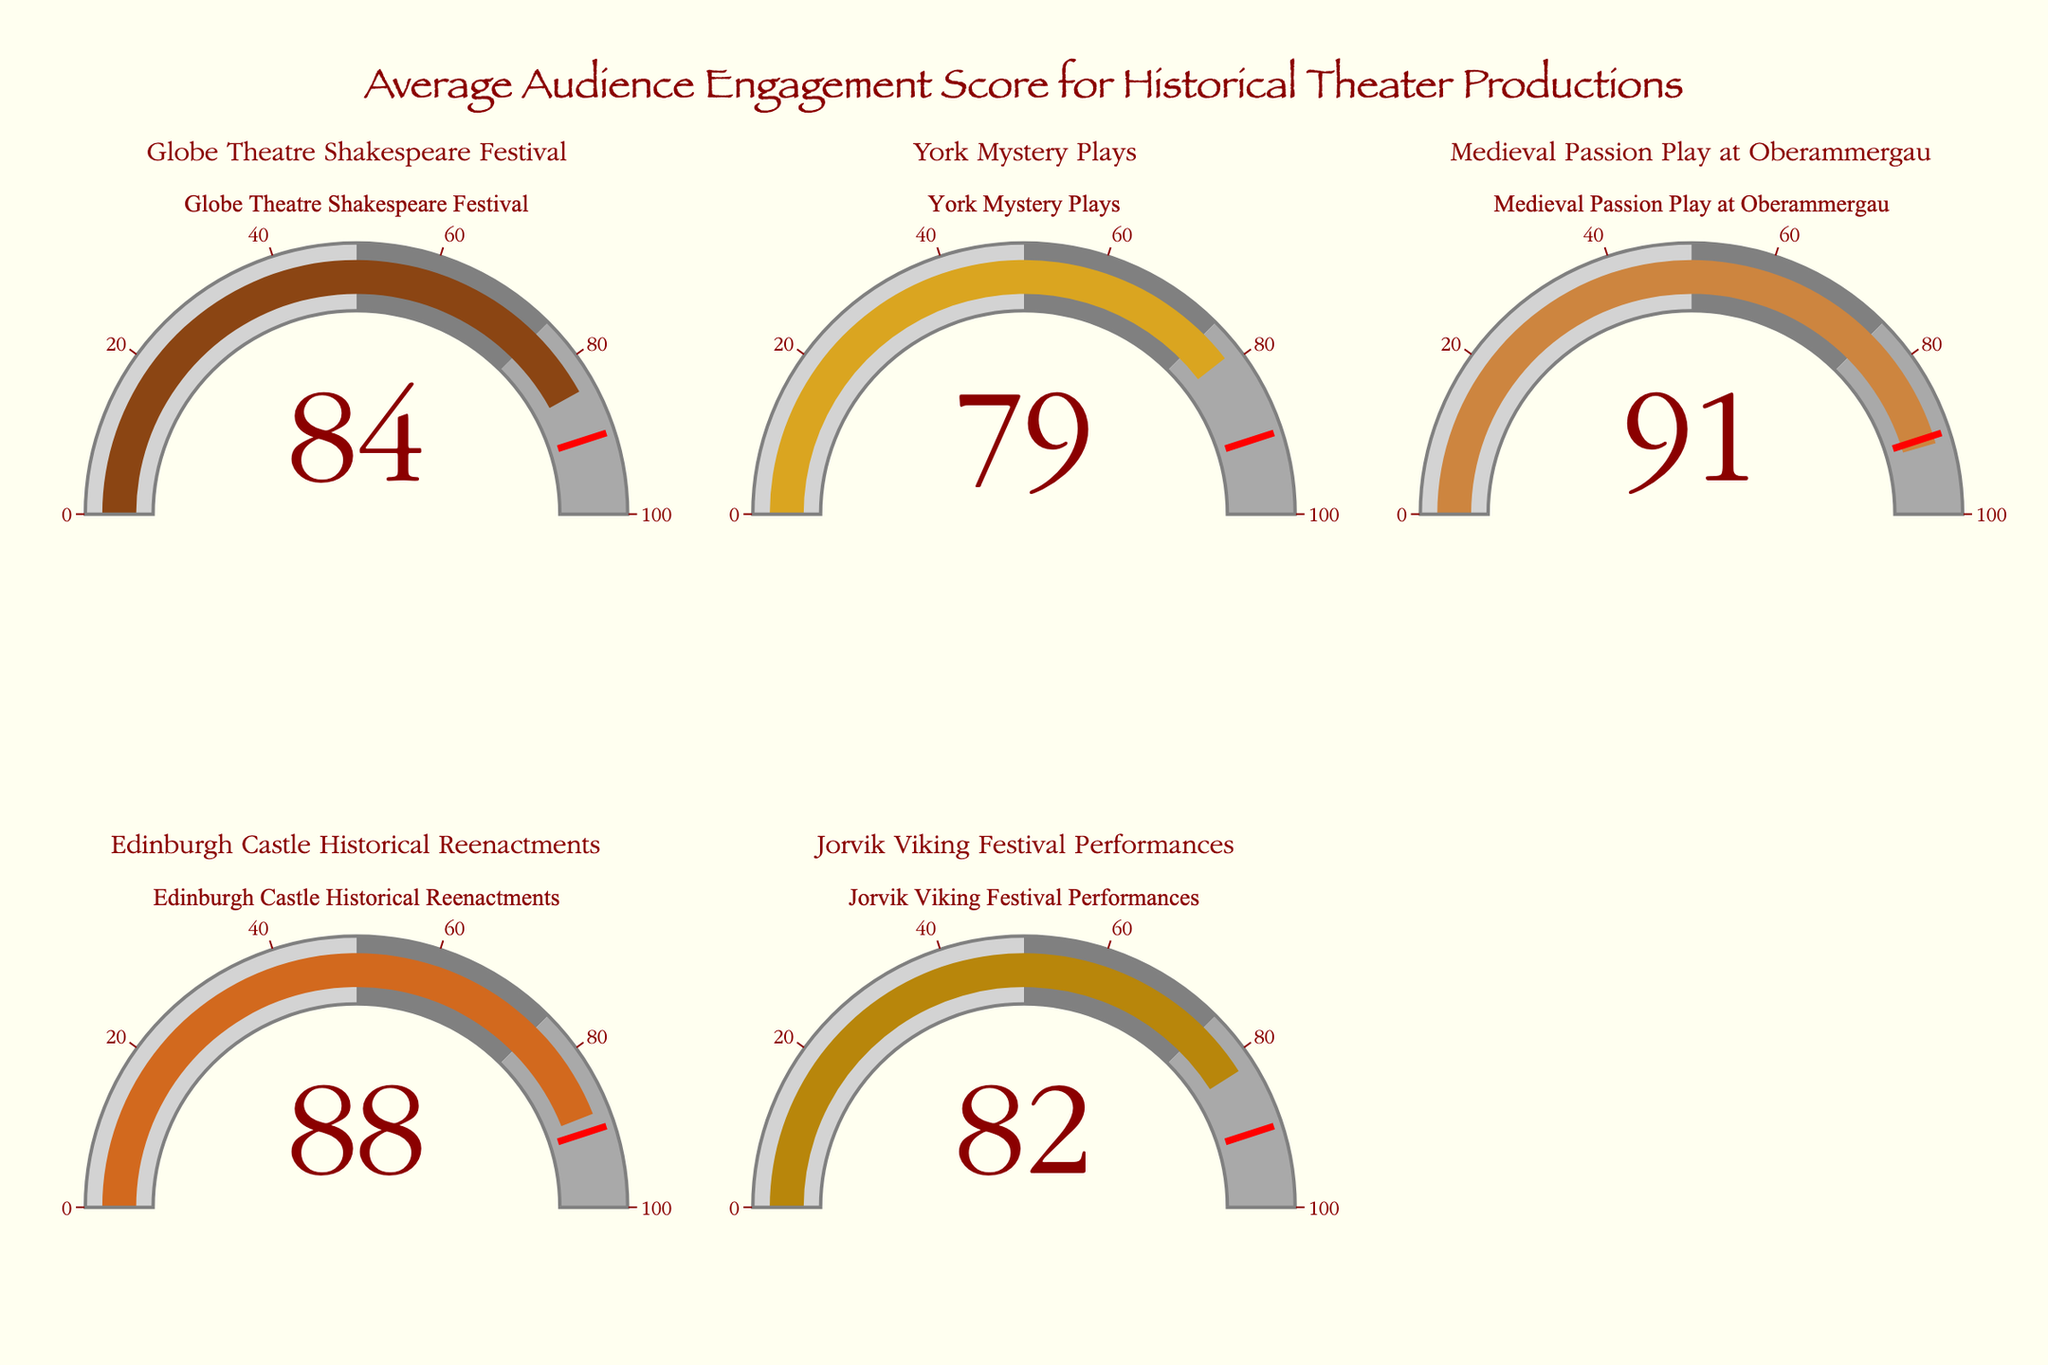What is the title of the figure? The title is usually displayed at the top of the figure and provides context about what the figure represents. In this case, it mentions the overall topic.
Answer: Average Audience Engagement Score for Historical Theater Productions How many gauge charts are there in the figure? Count the number of individual gauge charts shown.
Answer: 5 Which theater has the lowest audience engagement score? Identify and compare the audience engagement scores indicated on each gauge chart.
Answer: York Mystery Plays What's the difference in engagement scores between the Globe Theatre Shakespeare Festival and Edinburgh Castle Historical Reenactments? Subtract the engagement score of Edinburgh Castle Historical Reenactments from the score of Globe Theatre Shakespeare Festival: 84 - 88.
Answer: -4 What color represents the engagement score for the Medieval Passion Play at Oberammergau? Identify the specific color used for the gauge bar representing this theater's engagement score.
Answer: Dark Brownish Orange Which theater almost reaches the gauge threshold indicated by the red line? Check each gauge to see which value is closest to the red line, which is set at 90.
Answer: Edinburgh Castle Historical Reenactments Average the engagement scores of York Mystery Plays and Jorvik Viking Festival Performances. What is the result? Calculate the average by adding the two scores and then dividing by 2: (79 + 82) / 2.
Answer: 80.5 How many theaters have an engagement score above 80? Count the number of gauge charts showing a value greater than 80.
Answer: 4 Is the engagement score for Globe Theatre Shakespeare Festival higher than that for Jorvik Viking Festival Performances? Compare the engagement scores of both theaters: 84 vs. 82.
Answer: Yes What range is defined for the lowest engagement scores on the gauges? Look at the step range for the lightest color on the gauges, which signifies the lowest engagement score range.
Answer: 0 to 50 